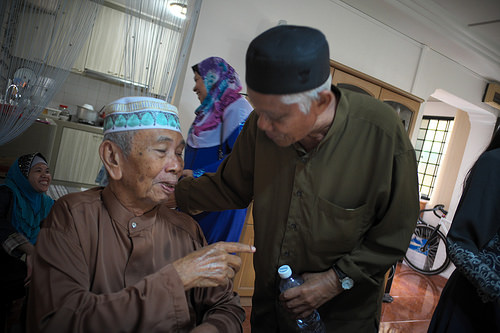<image>
Is there a bicycle behind the elderly man? Yes. From this viewpoint, the bicycle is positioned behind the elderly man, with the elderly man partially or fully occluding the bicycle. 